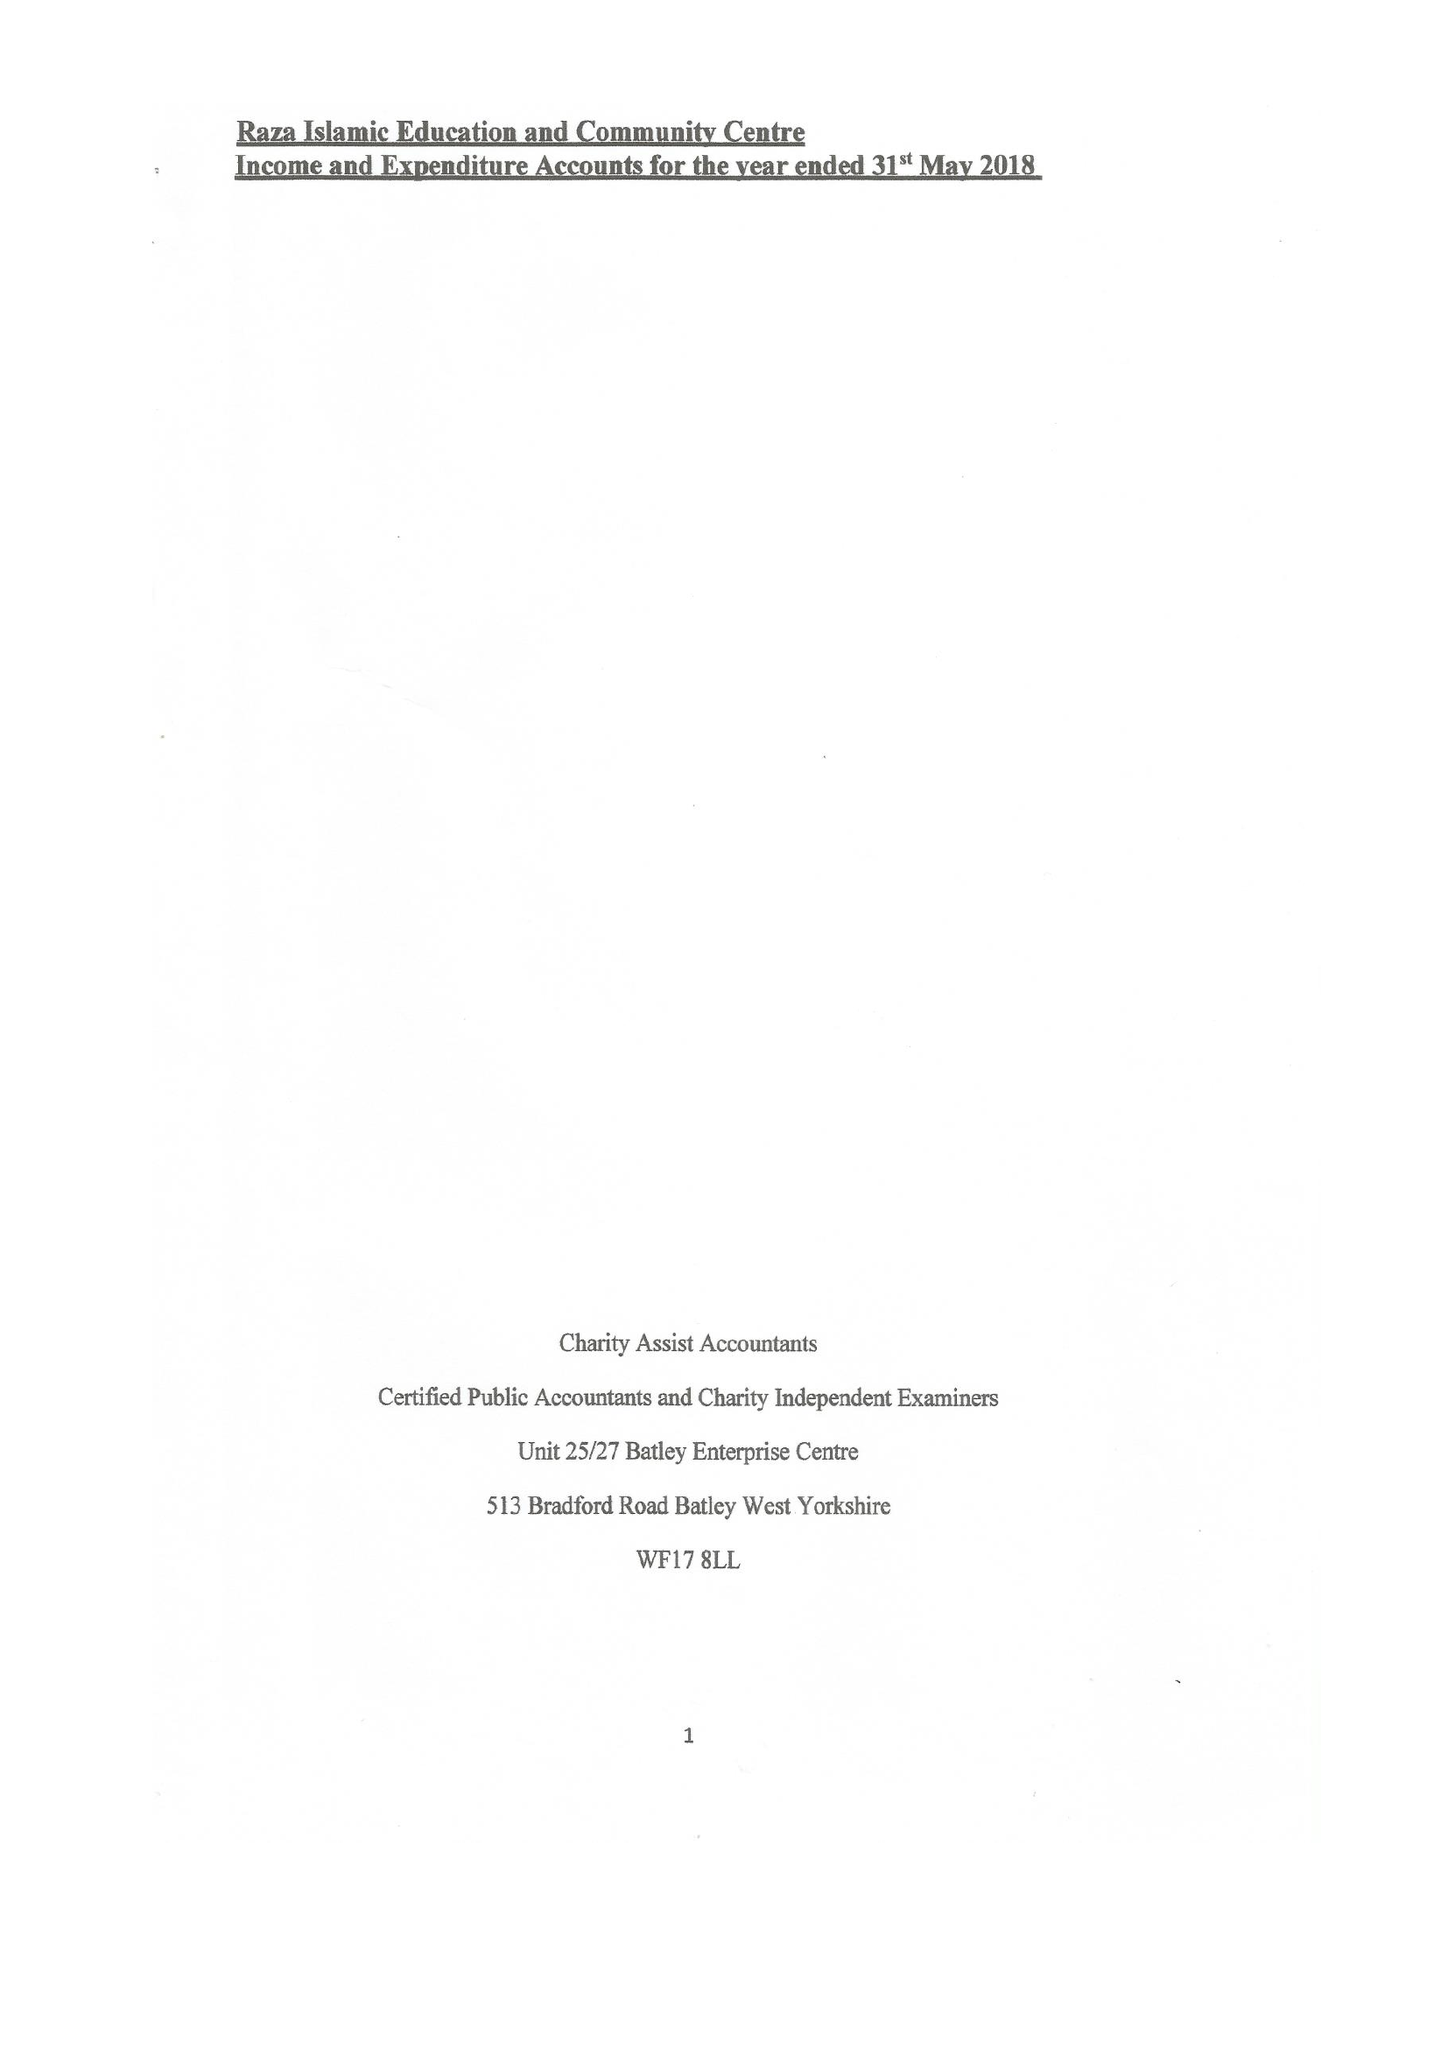What is the value for the charity_number?
Answer the question using a single word or phrase. 1147125 